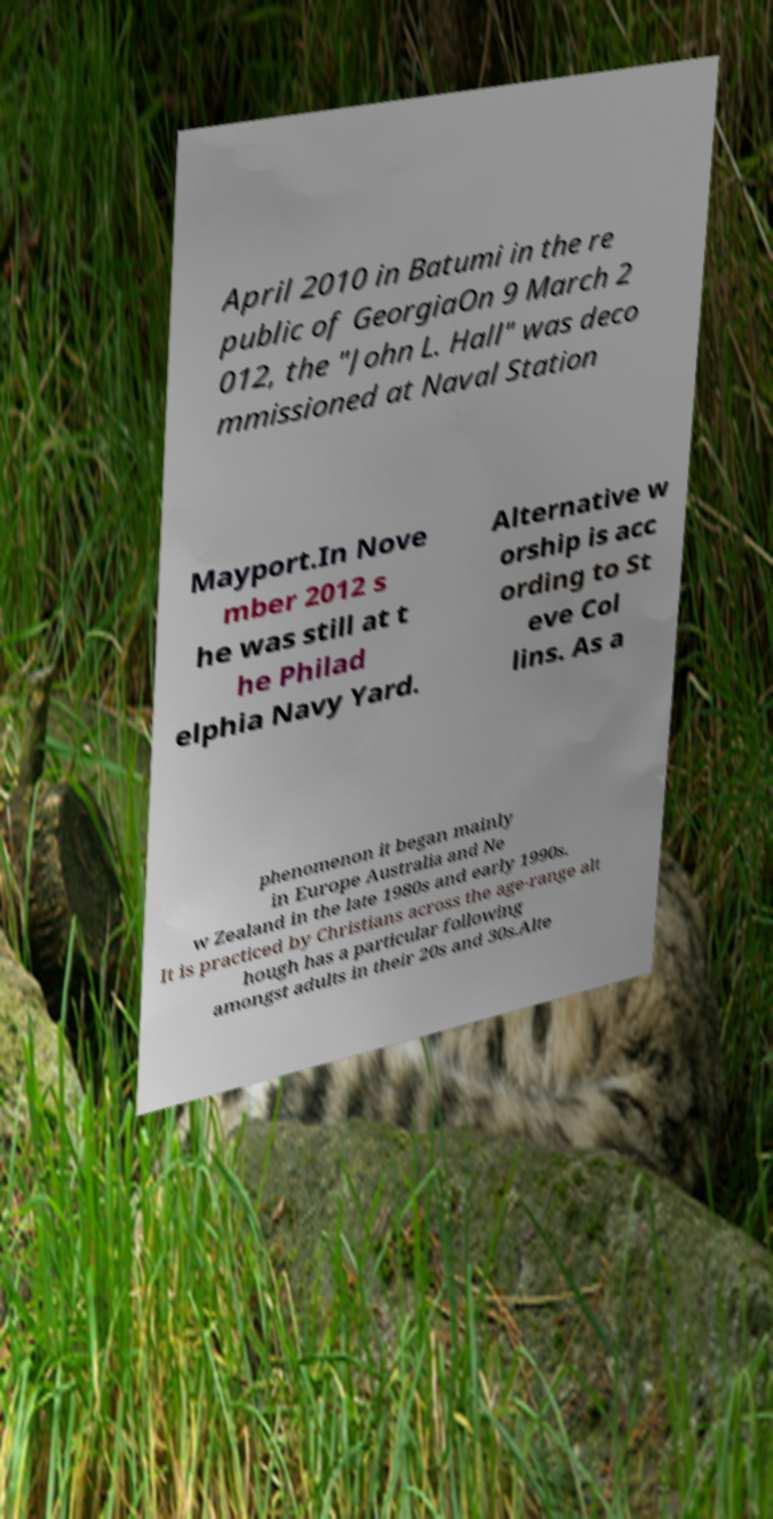For documentation purposes, I need the text within this image transcribed. Could you provide that? April 2010 in Batumi in the re public of GeorgiaOn 9 March 2 012, the "John L. Hall" was deco mmissioned at Naval Station Mayport.In Nove mber 2012 s he was still at t he Philad elphia Navy Yard. Alternative w orship is acc ording to St eve Col lins. As a phenomenon it began mainly in Europe Australia and Ne w Zealand in the late 1980s and early 1990s. It is practiced by Christians across the age-range alt hough has a particular following amongst adults in their 20s and 30s.Alte 